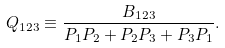Convert formula to latex. <formula><loc_0><loc_0><loc_500><loc_500>Q _ { 1 2 3 } \equiv \frac { B _ { 1 2 3 } } { P _ { 1 } P _ { 2 } + P _ { 2 } P _ { 3 } + P _ { 3 } P _ { 1 } } .</formula> 